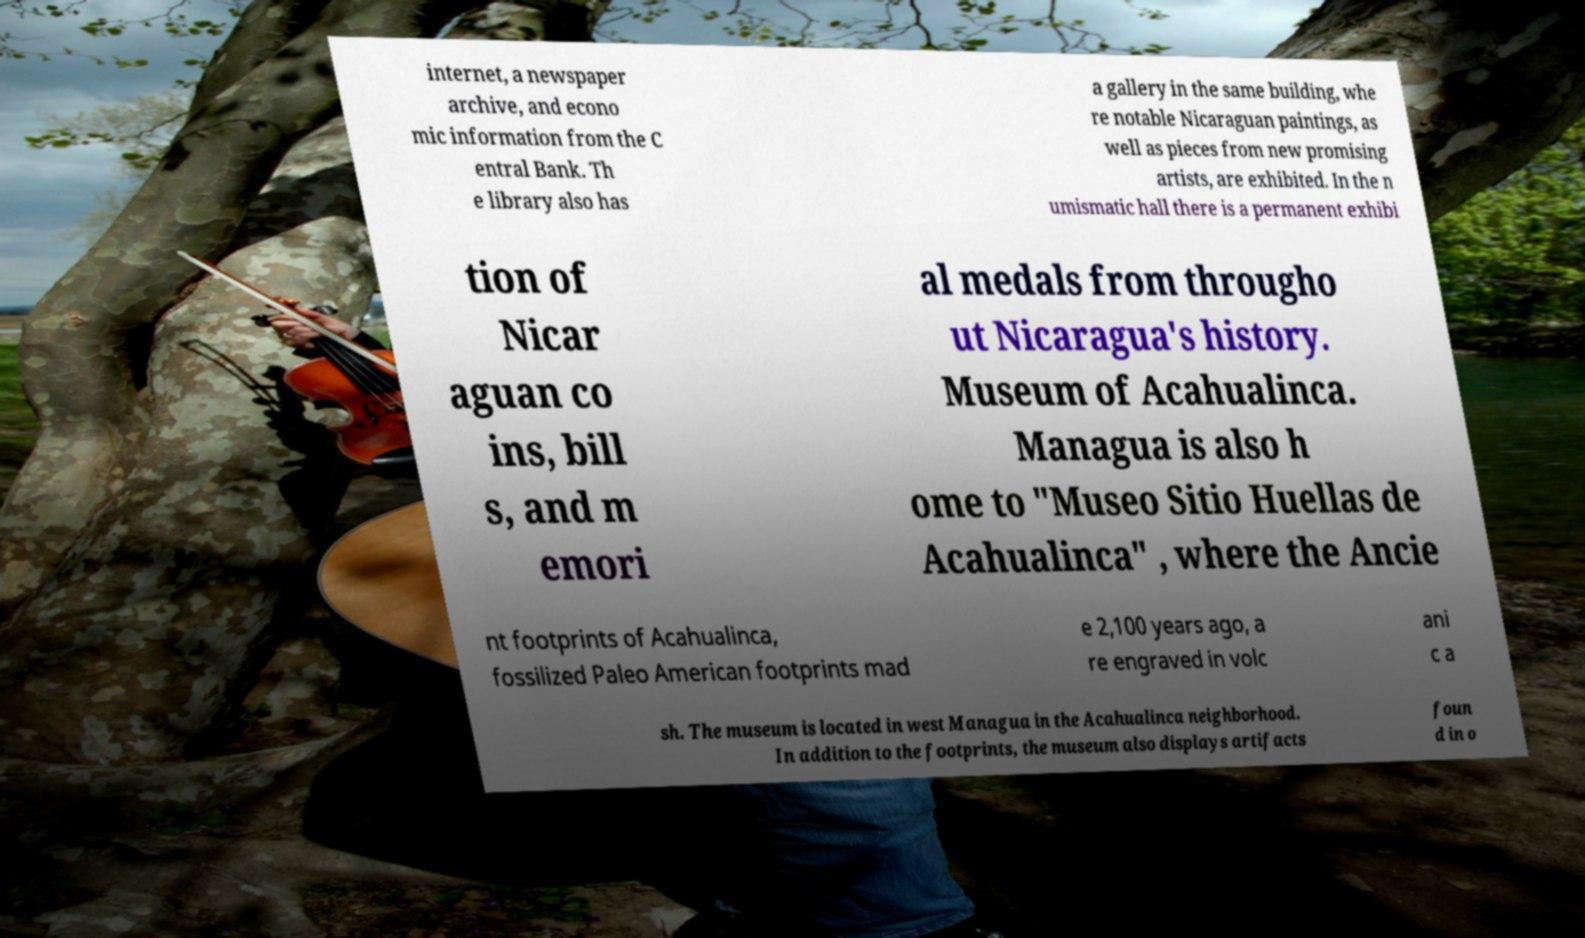There's text embedded in this image that I need extracted. Can you transcribe it verbatim? internet, a newspaper archive, and econo mic information from the C entral Bank. Th e library also has a gallery in the same building, whe re notable Nicaraguan paintings, as well as pieces from new promising artists, are exhibited. In the n umismatic hall there is a permanent exhibi tion of Nicar aguan co ins, bill s, and m emori al medals from througho ut Nicaragua's history. Museum of Acahualinca. Managua is also h ome to "Museo Sitio Huellas de Acahualinca" , where the Ancie nt footprints of Acahualinca, fossilized Paleo American footprints mad e 2,100 years ago, a re engraved in volc ani c a sh. The museum is located in west Managua in the Acahualinca neighborhood. In addition to the footprints, the museum also displays artifacts foun d in o 